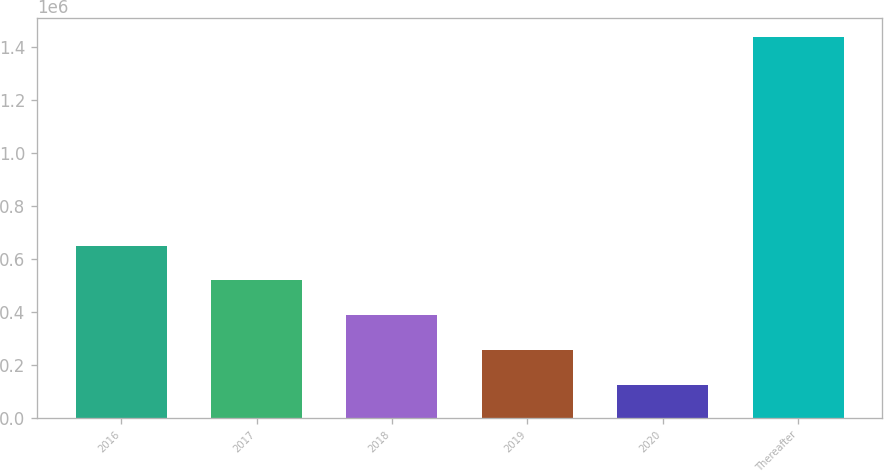Convert chart to OTSL. <chart><loc_0><loc_0><loc_500><loc_500><bar_chart><fcel>2016<fcel>2017<fcel>2018<fcel>2019<fcel>2020<fcel>Thereafter<nl><fcel>650151<fcel>518776<fcel>387401<fcel>256026<fcel>124651<fcel>1.4384e+06<nl></chart> 